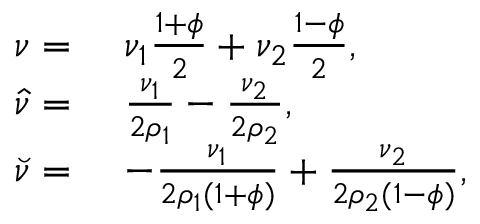<formula> <loc_0><loc_0><loc_500><loc_500>\begin{array} { r l } { \nu = } & { \nu _ { 1 } \frac { 1 + \phi } { 2 } + \nu _ { 2 } \frac { 1 - \phi } { 2 } , } \\ { \hat { \nu } = } & { \frac { \nu _ { 1 } } { 2 \rho _ { 1 } } - \frac { \nu _ { 2 } } { 2 \rho _ { 2 } } , } \\ { \breve { \nu } = } & { - \frac { \nu _ { 1 } } { 2 \rho _ { 1 } ( 1 + \phi ) } + \frac { \nu _ { 2 } } { 2 \rho _ { 2 } ( 1 - \phi ) } , } \end{array}</formula> 